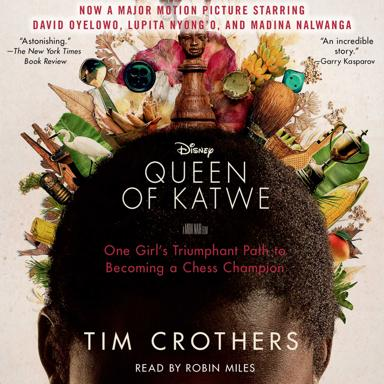What is the movie 'Queen of Katwe' about? ''Queen of Katwe'' details the uplifting and true story of Phiona Mutesi, a young girl from the slums of Uganda who, through her exceptional mind and the game of chess, finds hope and a chance to escape poverty. It's a narrative about overcoming adversity and the power of self-belief. 